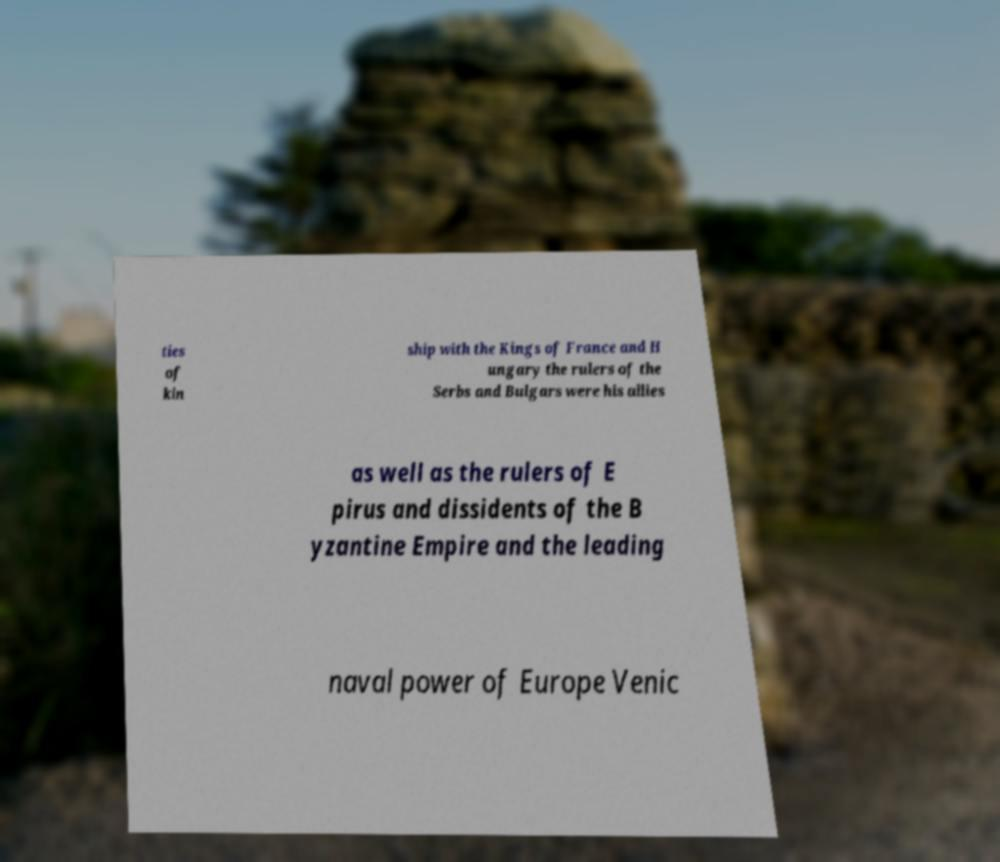For documentation purposes, I need the text within this image transcribed. Could you provide that? ties of kin ship with the Kings of France and H ungary the rulers of the Serbs and Bulgars were his allies as well as the rulers of E pirus and dissidents of the B yzantine Empire and the leading naval power of Europe Venic 